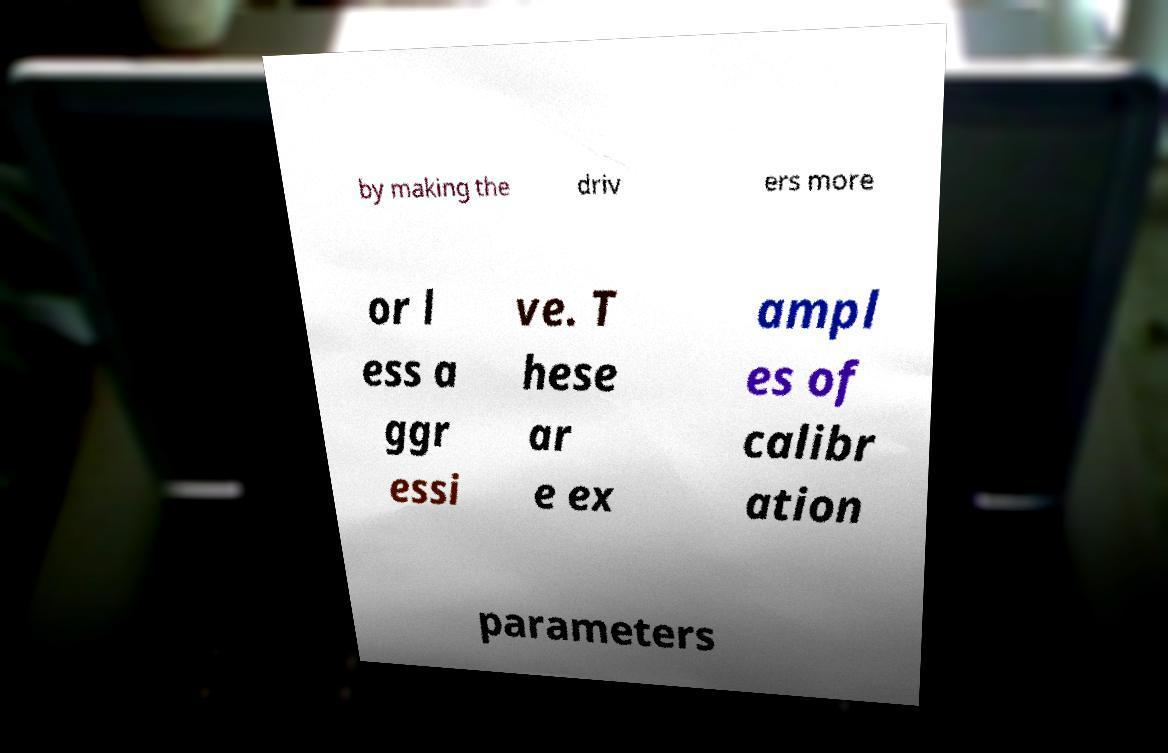Can you accurately transcribe the text from the provided image for me? by making the driv ers more or l ess a ggr essi ve. T hese ar e ex ampl es of calibr ation parameters 